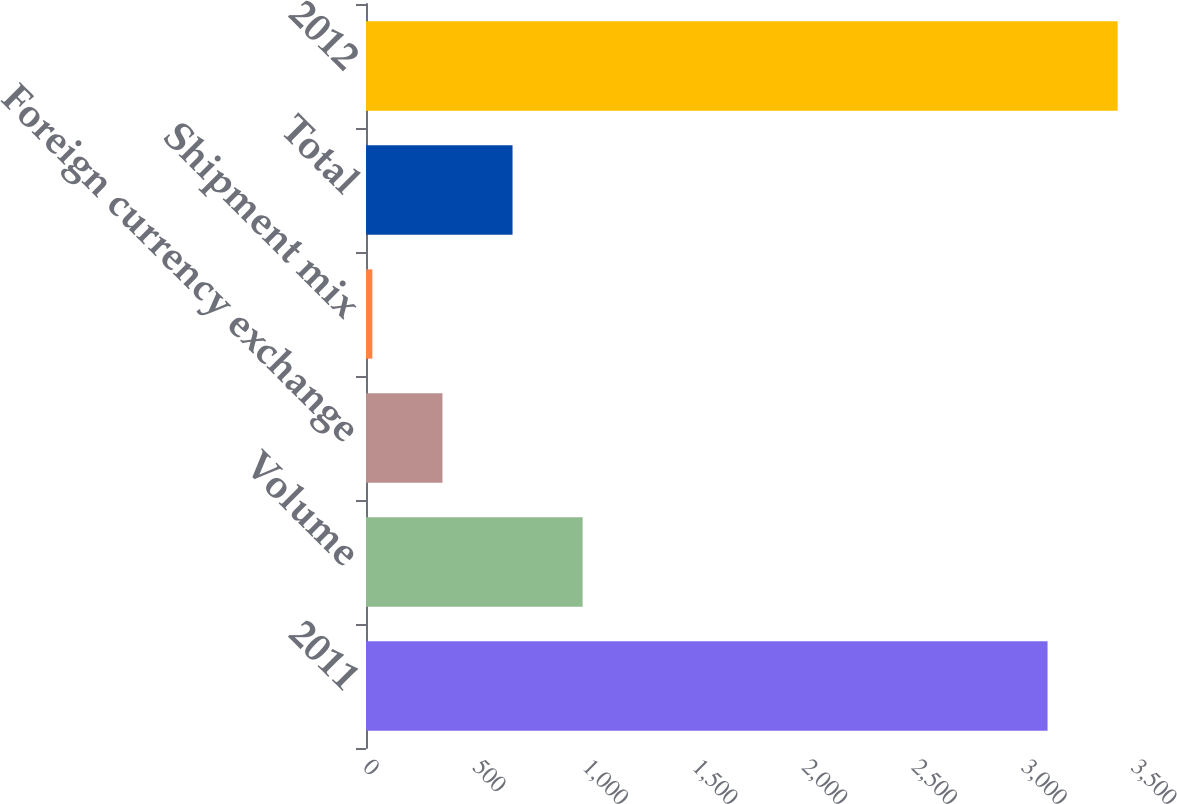<chart> <loc_0><loc_0><loc_500><loc_500><bar_chart><fcel>2011<fcel>Volume<fcel>Foreign currency exchange<fcel>Shipment mix<fcel>Total<fcel>2012<nl><fcel>3106<fcel>987.2<fcel>348.4<fcel>29<fcel>667.8<fcel>3425.4<nl></chart> 